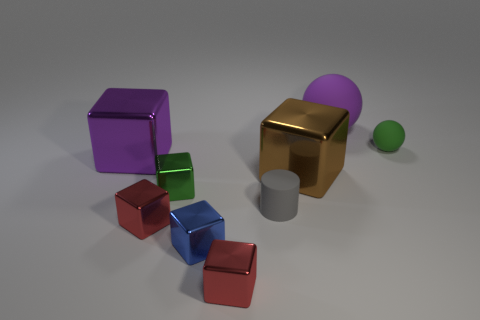There is a tiny matte thing that is to the right of the large matte sphere; does it have the same color as the small shiny thing behind the small gray cylinder?
Your response must be concise. Yes. Does the large rubber thing have the same shape as the green matte object?
Ensure brevity in your answer.  Yes. There is a small thing that is both behind the gray rubber cylinder and in front of the small sphere; what shape is it?
Your response must be concise. Cube. There is a small metallic thing that is the same color as the tiny sphere; what shape is it?
Your response must be concise. Cube. There is a large thing that is behind the big brown cube and on the right side of the small green block; what is it made of?
Offer a very short reply. Rubber. There is a green matte object that is the same size as the blue object; what shape is it?
Make the answer very short. Sphere. How big is the red shiny thing to the right of the green shiny object?
Your answer should be compact. Small. There is a object that is on the right side of the large thing that is behind the large purple object in front of the purple rubber thing; what color is it?
Your answer should be very brief. Green. The large block that is on the right side of the tiny red object to the right of the small blue metallic object is what color?
Give a very brief answer. Brown. Are there more large purple metal cubes behind the blue metal cube than matte spheres left of the large ball?
Your response must be concise. Yes. 